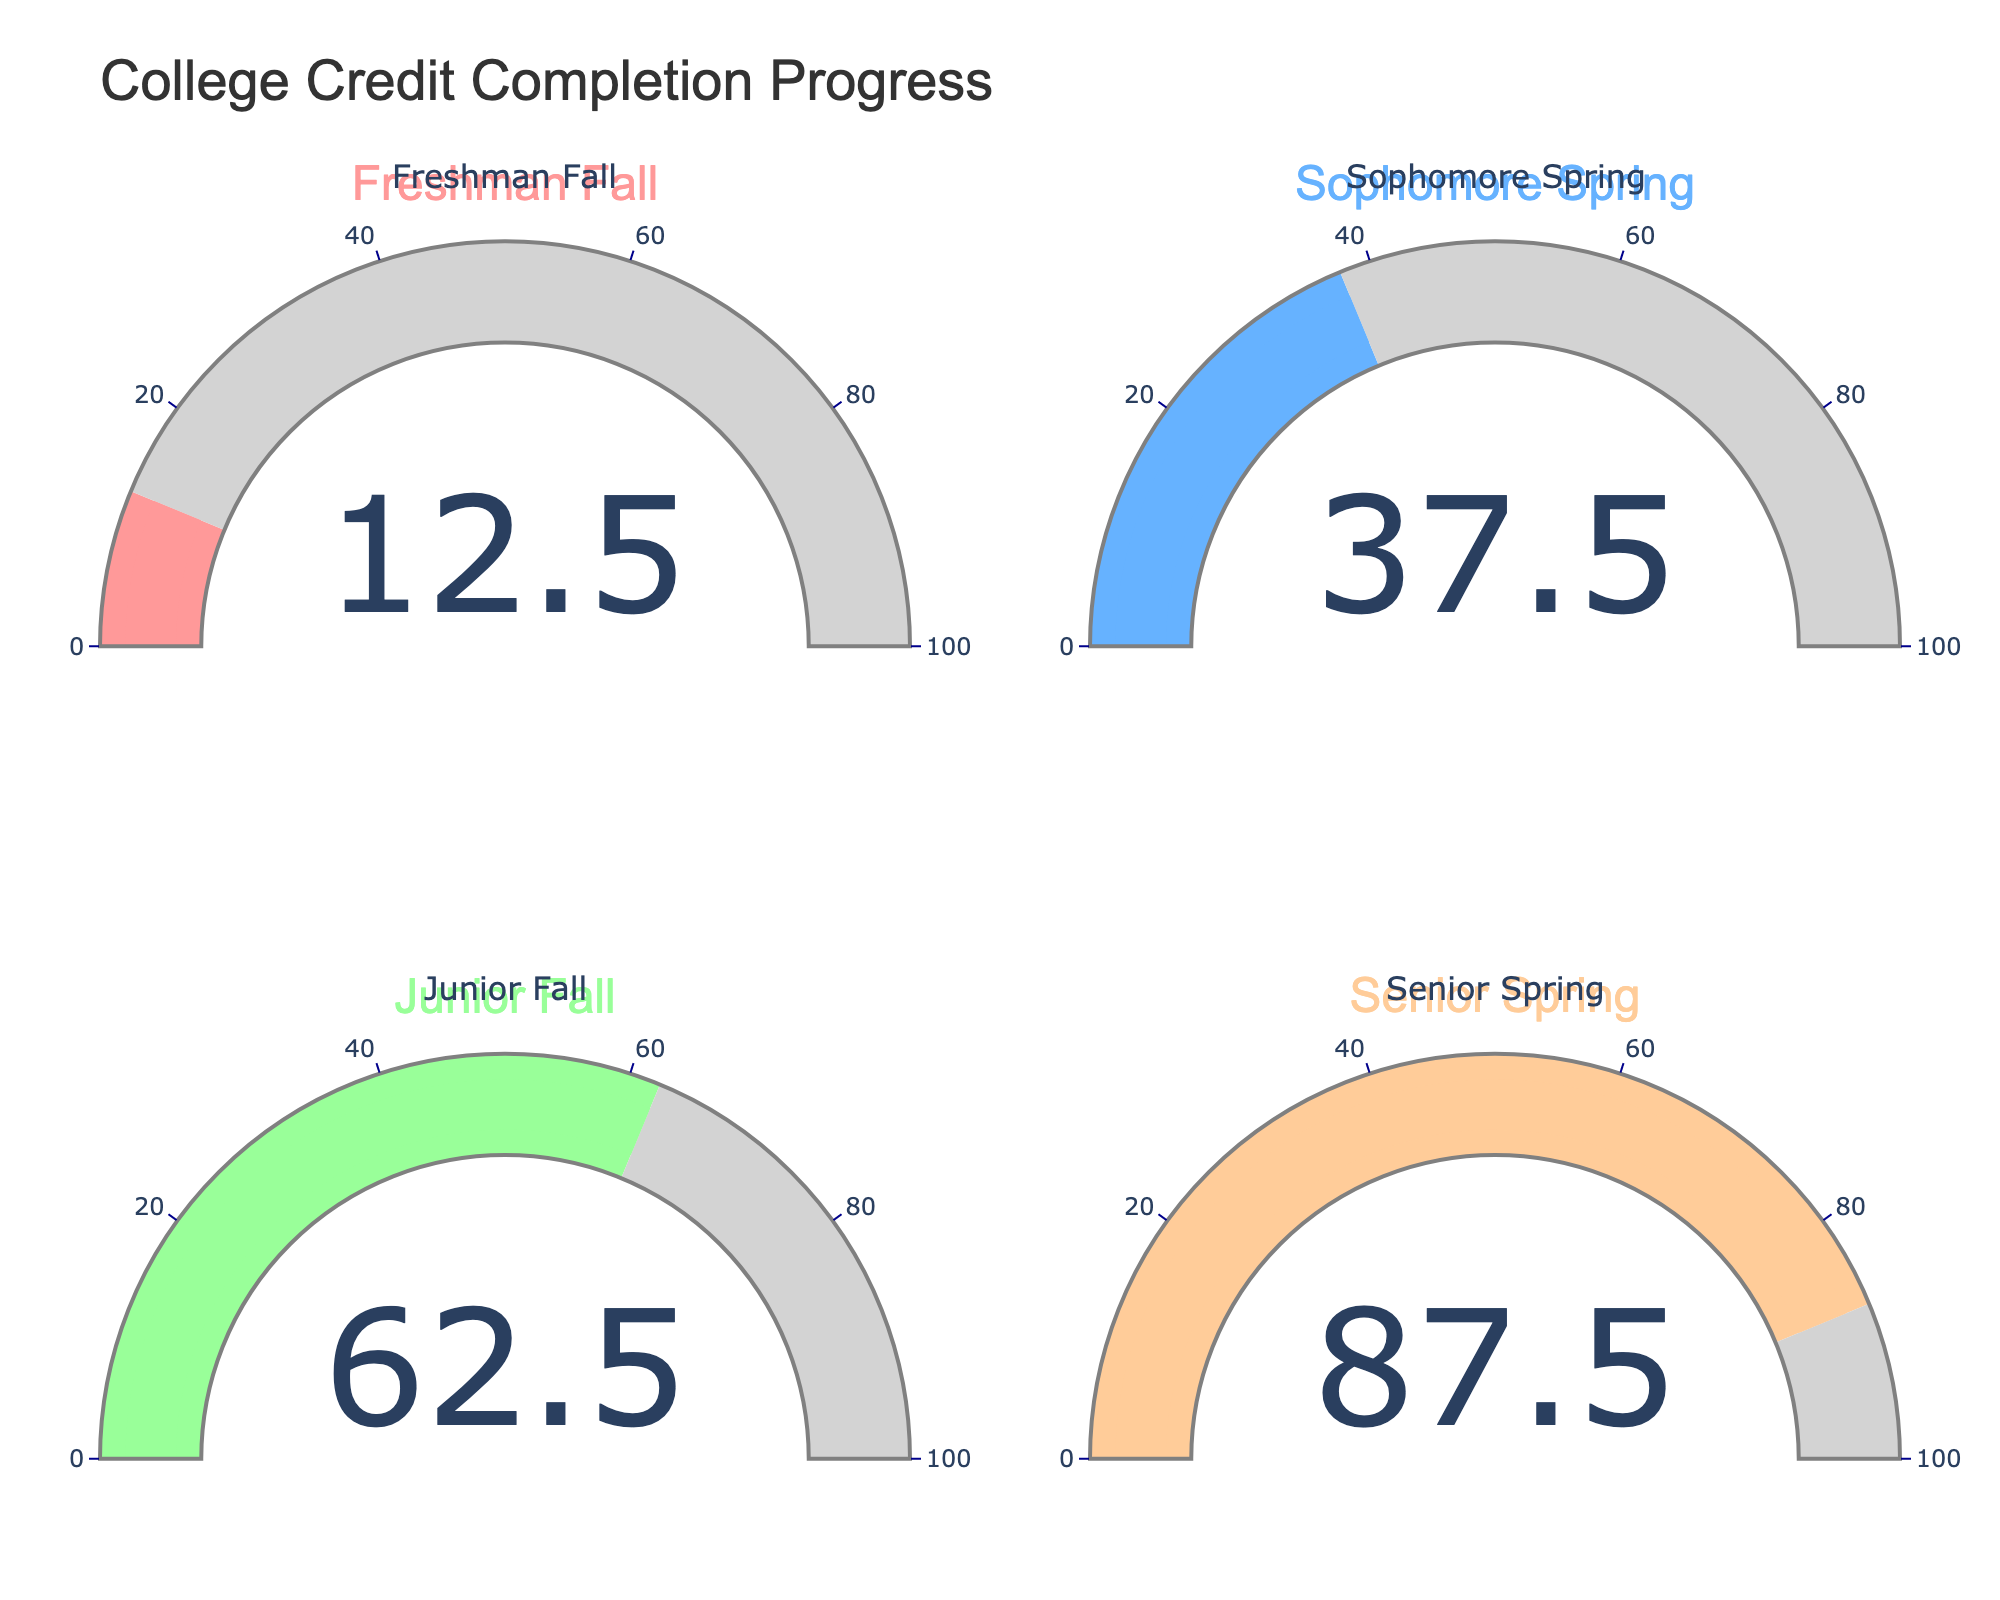What's the title of the chart? The title of the chart is located at the top and centered within the layout, which can be identified visually.
Answer: College Credit Completion Progress What percentage completion is shown for the Sophomore Spring semester? In the "Sophomore Spring" gauge, the number displayed represents the completion percentage.
Answer: 37.5% What's the difference in completion percentage between Freshman Fall and Senior Spring? The Freshman Fall gauge displays 12.5%, and the Senior Spring gauge displays 87.5%. Subtracting these gives us 87.5% - 12.5% = 75%.
Answer: 75% Which semester has the highest completion percentage? By examining all four gauges, the highest value is found in the "Senior Spring" gauge.
Answer: Senior Spring What is the average completion percentage across all semesters? Sum the percentages from all four semesters (12.5 + 37.5 + 62.5 + 87.5) = 200. Divide this sum by 4 (number of semesters): 200 / 4 = 50%.
Answer: 50% How does the color of the Freshman Fall gauge differ from the color of the Junior Fall gauge? The Freshman Fall gauge uses a red color, while the Junior Fall gauge uses a green color.
Answer: Freshman Fall is red; Junior Fall is green Is the completion percentage for Junior Fall closer to Freshman Fall or Senior Spring? Junior Fall has 62.5%. The difference with Freshman Fall (12.5%) is 50%, while the difference with Senior Spring (87.5%) is 25%. Therefore, it is closer to Senior Spring.
Answer: Senior Spring What is the total completion percentage added from Freshman Fall to Junior Fall? Add the percentages from Freshman Fall, Sophomore Spring, and Junior Fall: 12.5 + 37.5 + 62.5 = 112.5%.
Answer: 112.5% Which semester shows a percentage completion closest to half completion (50%)? Half completion is 50%. The most proximate value is 37.5% (Sophomore Spring).
Answer: Sophomore Spring How much more completion percentage does Junior Fall have compared to Sophomore Spring? Junior Fall has 62.5%, and Sophomore Spring has 37.5%. Subtracting these gives us 62.5% - 37.5% = 25%.
Answer: 25% 